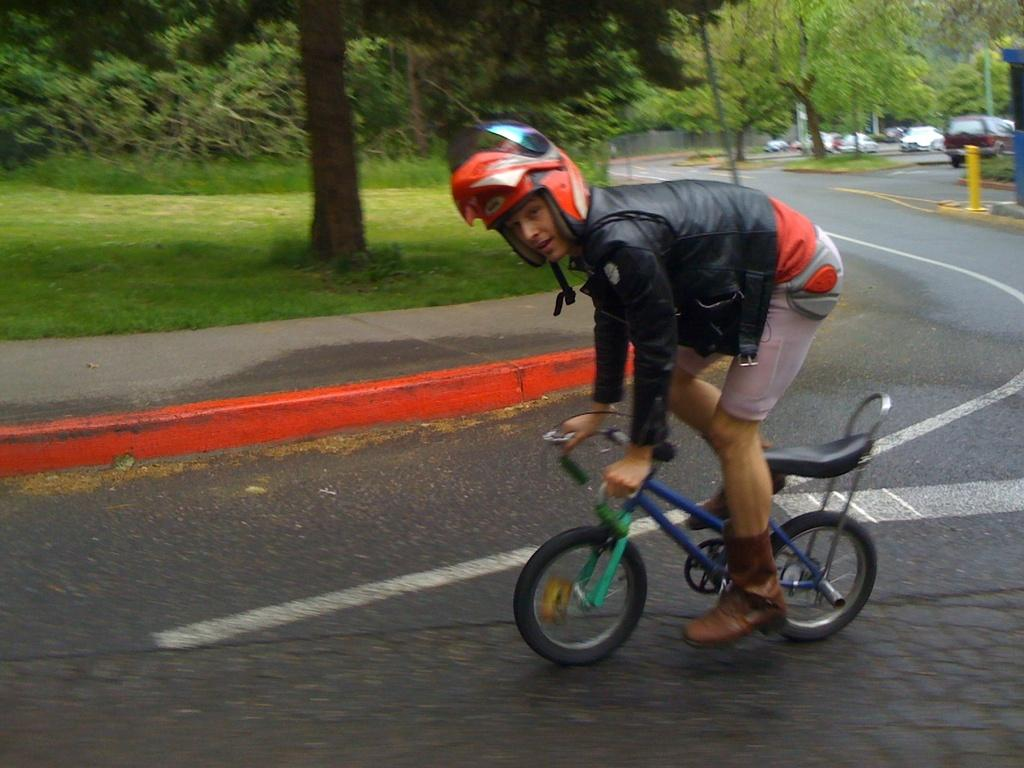What is the main subject of the image? There is a person riding a bicycle in the image. What is the person wearing? The person is wearing a black jacket. What can be seen in the background of the image? There are vehicles and trees with green color visible in the background of the image. What type of chin can be seen on the bicycle in the person in the image? There is no chin visible on the person in the image, as the person's face is not shown. How many cents are visible on the bicycle in the image? There are no cents present in the image; it features a person riding a bicycle and the background. 